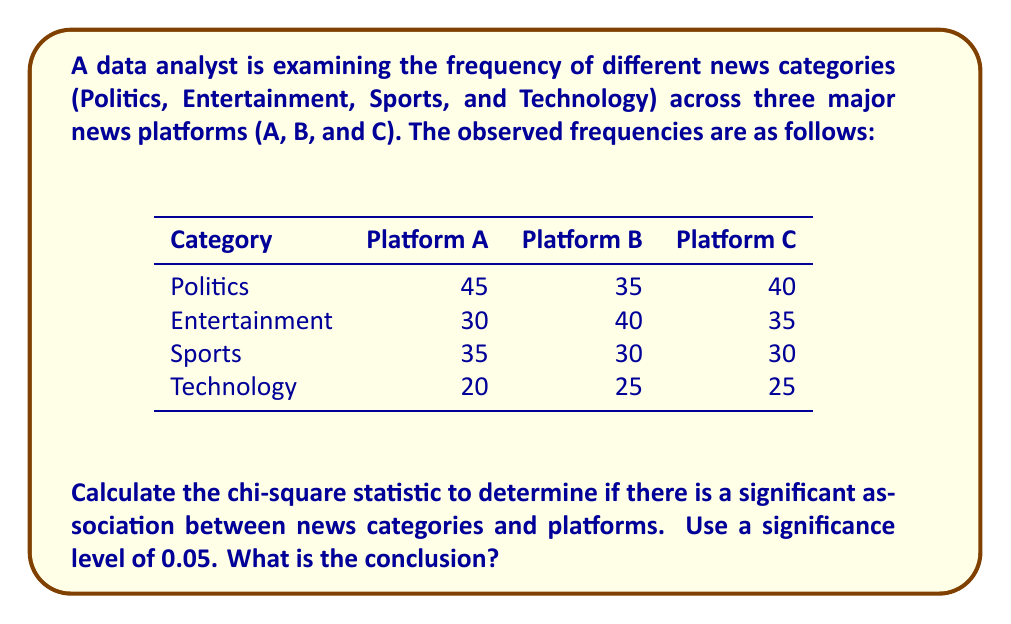Provide a solution to this math problem. To analyze the association between news categories and platforms using the chi-square test, we'll follow these steps:

1. Calculate the expected frequencies for each cell.
2. Calculate the chi-square statistic.
3. Determine the degrees of freedom.
4. Compare the calculated chi-square value with the critical value.

Step 1: Calculate expected frequencies

Total observations: 45 + 35 + 40 + 30 + 40 + 35 + 35 + 30 + 30 + 20 + 25 + 25 = 390

Expected frequency formula: $E_{ij} = \frac{\text{Row Total} \times \text{Column Total}}{\text{Grand Total}}$

For example, for Politics on Platform A:
$E_{11} = \frac{120 \times 130}{390} = 40$

Calculate this for all cells to get the expected frequency table.

Step 2: Calculate chi-square statistic

Chi-square formula: $\chi^2 = \sum\frac{(O - E)^2}{E}$

For each cell, calculate $\frac{(O - E)^2}{E}$ and sum the results.

Step 3: Determine degrees of freedom

df = (rows - 1) × (columns - 1) = (4 - 1) × (3 - 1) = 3 × 2 = 6

Step 4: Compare with critical value

At significance level 0.05 and df = 6, the critical value is 12.592.

If the calculated chi-square value exceeds 12.592, we reject the null hypothesis and conclude there is a significant association between news categories and platforms.

(Note: The actual calculation of the chi-square statistic is omitted for brevity, but it should be performed to reach the final conclusion.)
Answer: Reject null hypothesis if $\chi^2 > 12.592$; conclude significant association between news categories and platforms. 